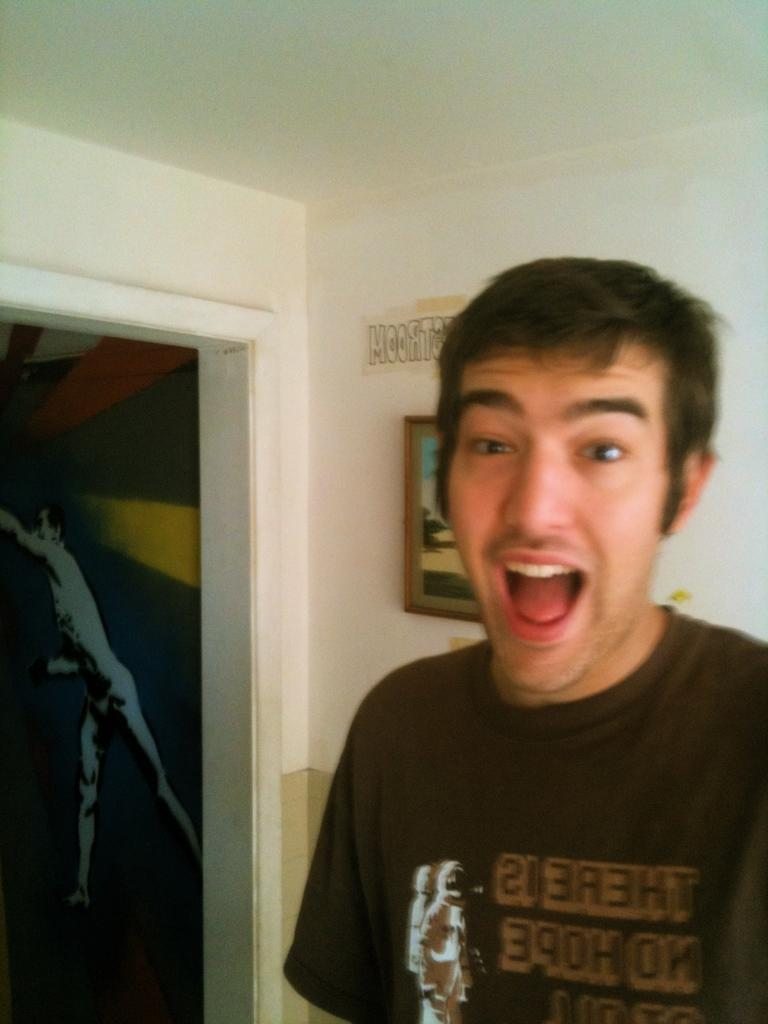What is present in the image? There is a person in the image. Where is the entrance located in the image? The entrance is visible on the left side of the image. What is one of the features of the image? There is a wall in the image. What is attached to the wall? A photo frame is attached to the wall. What part of the person can be seen in the image? The backside of the person is visible. What type of meal is being prepared in the image? There is no indication of a meal being prepared in the image. Does the person in the image have any debt? There is no information about the person's debt in the image. 